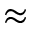Convert formula to latex. <formula><loc_0><loc_0><loc_500><loc_500>\approx</formula> 